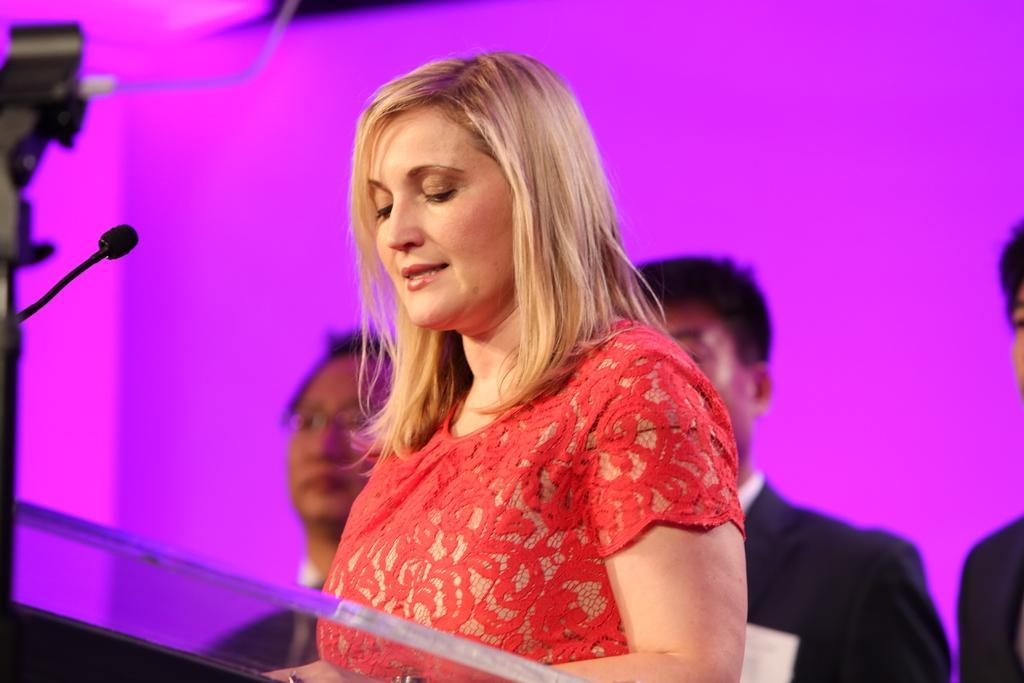In one or two sentences, can you explain what this image depicts? In this image on the foreground a lady is standing wearing red dress. In front of her there is a podium on it there is a mic. In the background three men wearing black suits are standing. 